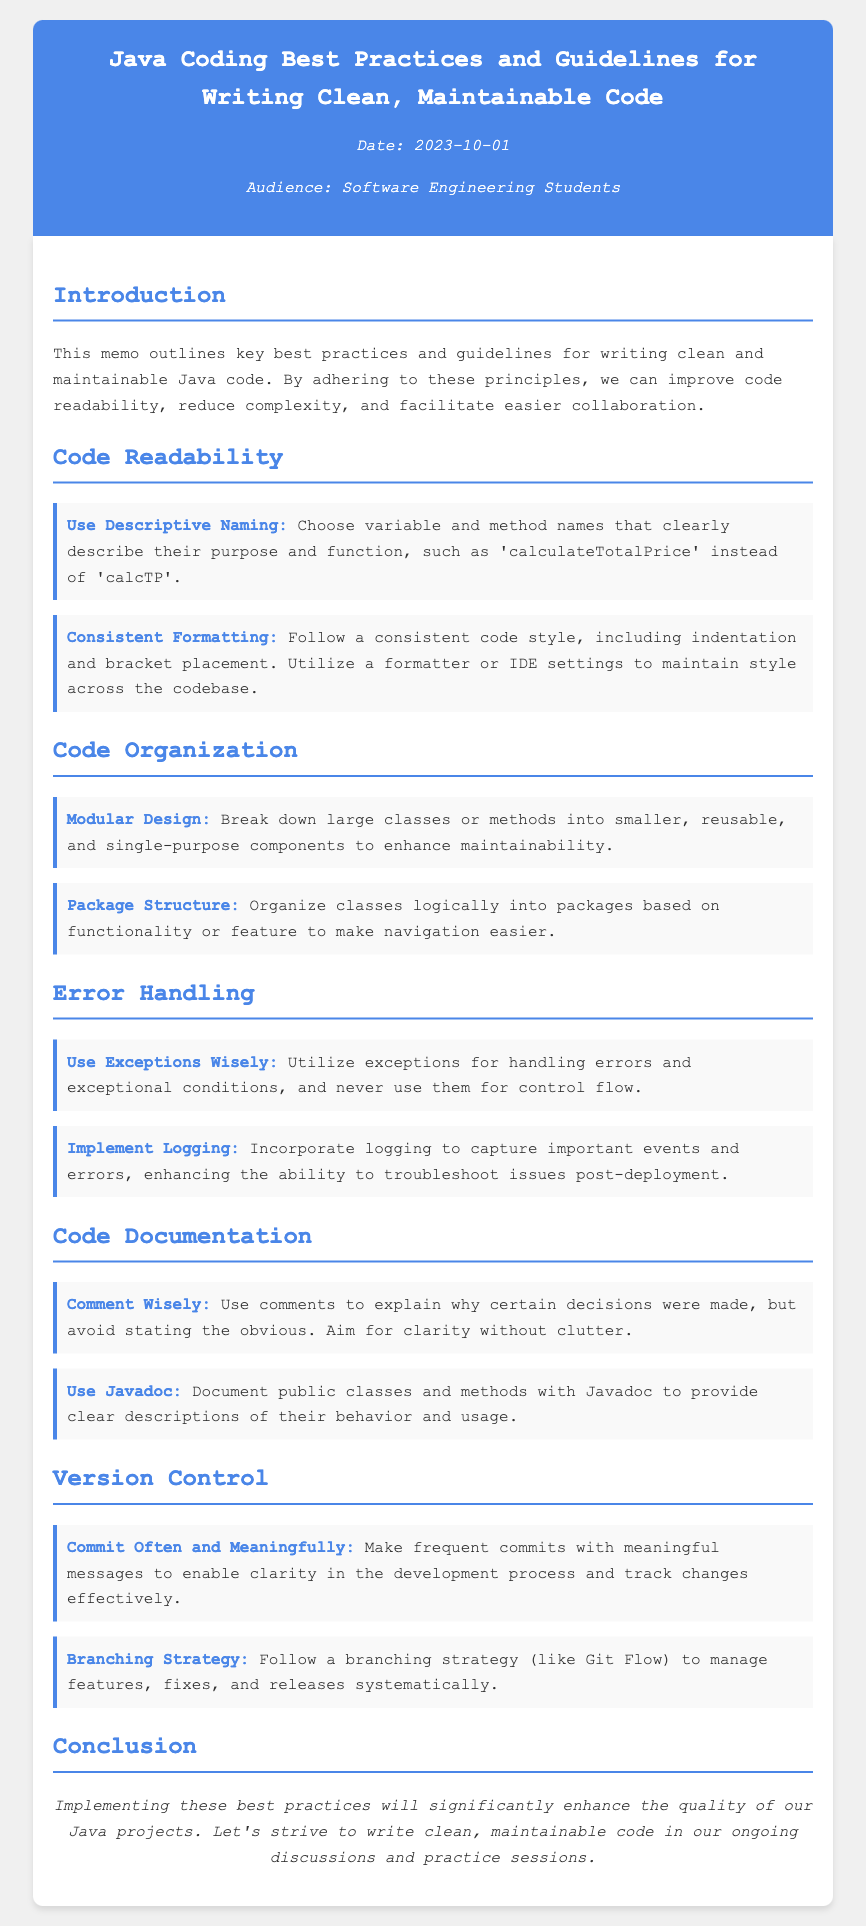What is the title of the memo? The title of the memo is prominently displayed in the header section, indicating its purpose.
Answer: Java Coding Best Practices and Guidelines for Writing Clean, Maintainable Code When was the memo published? The publication date is located under the title in the meta section of the document.
Answer: 2023-10-01 Who is the intended audience for the memo? The intended audience is specified in the meta section and outlines who the memo is aimed at.
Answer: Software Engineering Students What is the main purpose of the memo? The introduction section describes the main objective of the memo regarding coding practices.
Answer: To outline key best practices and guidelines for writing clean and maintainable Java code What principle emphasizes the use of meaningful names? The first bullet under the Code Readability section highlights this specific practice.
Answer: Use Descriptive Naming How should classes and methods be organized according to the memo? The Code Organization section contains guidelines for organizing classes and methods effectively.
Answer: Modular Design What does the memo recommend for handling errors? The Error Handling section provides advice on how to manage errors appropriately.
Answer: Use Exceptions Wisely What is the recommended strategy for version control mentions in the memo? The Version Control section specifies a systematic approach for managing development tasks.
Answer: Branching Strategy What type of documentation does the memo suggest using for Java code? The Code Documentation section recommends a specific type of documentation for developers to employ.
Answer: Javadoc 